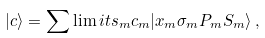<formula> <loc_0><loc_0><loc_500><loc_500>| c \rangle = \sum \lim i t s _ { m } c _ { m } | x _ { m } \sigma _ { m } P _ { m } S _ { m } \rangle \, ,</formula> 